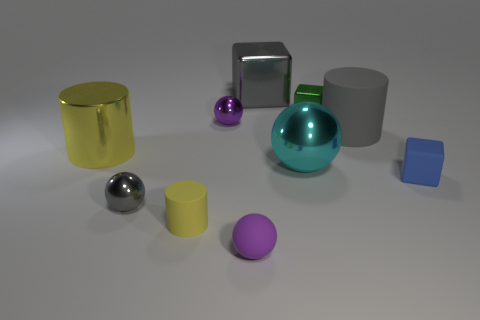There is a tiny rubber object on the left side of the small ball that is behind the big cylinder to the left of the small yellow rubber cylinder; what shape is it?
Make the answer very short. Cylinder. How many objects are either blue metal balls or purple objects that are in front of the blue rubber thing?
Keep it short and to the point. 1. What size is the gray thing that is in front of the big gray rubber cylinder?
Your response must be concise. Small. What is the shape of the big thing that is the same color as the tiny cylinder?
Offer a terse response. Cylinder. Is the material of the small yellow object the same as the tiny purple object behind the tiny yellow rubber cylinder?
Your response must be concise. No. What number of small matte balls are in front of the tiny block behind the large metal object to the left of the tiny matte sphere?
Give a very brief answer. 1. How many green objects are big matte cylinders or rubber cylinders?
Provide a succinct answer. 0. The gray metallic thing on the right side of the purple matte sphere has what shape?
Give a very brief answer. Cube. There is a cylinder that is the same size as the gray shiny sphere; what color is it?
Keep it short and to the point. Yellow. There is a green shiny thing; does it have the same shape as the purple object that is behind the large yellow cylinder?
Offer a terse response. No. 